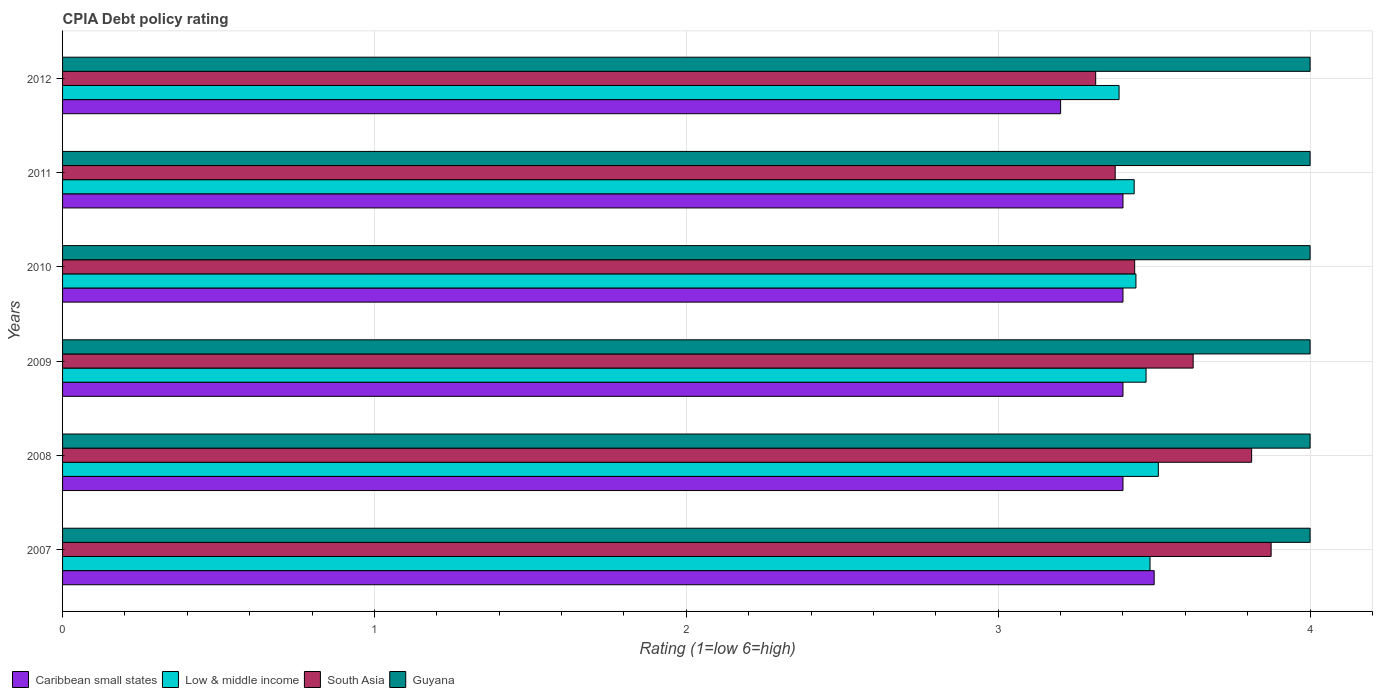How many different coloured bars are there?
Your answer should be compact. 4. Are the number of bars per tick equal to the number of legend labels?
Give a very brief answer. Yes. How many bars are there on the 2nd tick from the top?
Keep it short and to the point. 4. How many bars are there on the 6th tick from the bottom?
Provide a succinct answer. 4. In how many cases, is the number of bars for a given year not equal to the number of legend labels?
Your response must be concise. 0. Across all years, what is the maximum CPIA rating in Guyana?
Make the answer very short. 4. In which year was the CPIA rating in Guyana maximum?
Your answer should be very brief. 2007. What is the total CPIA rating in Low & middle income in the graph?
Your answer should be compact. 20.74. What is the difference between the CPIA rating in Low & middle income in 2009 and that in 2011?
Provide a short and direct response. 0.04. What is the difference between the CPIA rating in Caribbean small states in 2011 and the CPIA rating in South Asia in 2012?
Your response must be concise. 0.09. What is the average CPIA rating in South Asia per year?
Provide a short and direct response. 3.57. In the year 2007, what is the difference between the CPIA rating in Guyana and CPIA rating in Caribbean small states?
Provide a succinct answer. 0.5. In how many years, is the CPIA rating in Caribbean small states greater than 0.6000000000000001 ?
Provide a succinct answer. 6. What is the ratio of the CPIA rating in South Asia in 2010 to that in 2011?
Give a very brief answer. 1.02. What is the difference between the highest and the second highest CPIA rating in Low & middle income?
Your response must be concise. 0.03. What is the difference between the highest and the lowest CPIA rating in Caribbean small states?
Ensure brevity in your answer.  0.3. In how many years, is the CPIA rating in Guyana greater than the average CPIA rating in Guyana taken over all years?
Your response must be concise. 0. Is it the case that in every year, the sum of the CPIA rating in Caribbean small states and CPIA rating in Guyana is greater than the sum of CPIA rating in South Asia and CPIA rating in Low & middle income?
Offer a terse response. Yes. What does the 4th bar from the top in 2012 represents?
Your response must be concise. Caribbean small states. What does the 1st bar from the bottom in 2008 represents?
Make the answer very short. Caribbean small states. Is it the case that in every year, the sum of the CPIA rating in Guyana and CPIA rating in Low & middle income is greater than the CPIA rating in South Asia?
Ensure brevity in your answer.  Yes. How many bars are there?
Your answer should be very brief. 24. Are all the bars in the graph horizontal?
Your answer should be compact. Yes. How many years are there in the graph?
Your answer should be very brief. 6. Are the values on the major ticks of X-axis written in scientific E-notation?
Keep it short and to the point. No. Where does the legend appear in the graph?
Give a very brief answer. Bottom left. How many legend labels are there?
Offer a terse response. 4. What is the title of the graph?
Your answer should be compact. CPIA Debt policy rating. Does "Euro area" appear as one of the legend labels in the graph?
Keep it short and to the point. No. What is the label or title of the X-axis?
Ensure brevity in your answer.  Rating (1=low 6=high). What is the label or title of the Y-axis?
Provide a short and direct response. Years. What is the Rating (1=low 6=high) of Low & middle income in 2007?
Ensure brevity in your answer.  3.49. What is the Rating (1=low 6=high) of South Asia in 2007?
Make the answer very short. 3.88. What is the Rating (1=low 6=high) in Low & middle income in 2008?
Keep it short and to the point. 3.51. What is the Rating (1=low 6=high) of South Asia in 2008?
Make the answer very short. 3.81. What is the Rating (1=low 6=high) in Caribbean small states in 2009?
Offer a terse response. 3.4. What is the Rating (1=low 6=high) in Low & middle income in 2009?
Keep it short and to the point. 3.47. What is the Rating (1=low 6=high) in South Asia in 2009?
Make the answer very short. 3.62. What is the Rating (1=low 6=high) of Guyana in 2009?
Your response must be concise. 4. What is the Rating (1=low 6=high) in Caribbean small states in 2010?
Keep it short and to the point. 3.4. What is the Rating (1=low 6=high) in Low & middle income in 2010?
Make the answer very short. 3.44. What is the Rating (1=low 6=high) in South Asia in 2010?
Give a very brief answer. 3.44. What is the Rating (1=low 6=high) in Guyana in 2010?
Your response must be concise. 4. What is the Rating (1=low 6=high) in Low & middle income in 2011?
Your answer should be very brief. 3.44. What is the Rating (1=low 6=high) in South Asia in 2011?
Provide a succinct answer. 3.38. What is the Rating (1=low 6=high) in Guyana in 2011?
Provide a succinct answer. 4. What is the Rating (1=low 6=high) in Caribbean small states in 2012?
Your answer should be compact. 3.2. What is the Rating (1=low 6=high) in Low & middle income in 2012?
Your response must be concise. 3.39. What is the Rating (1=low 6=high) of South Asia in 2012?
Give a very brief answer. 3.31. What is the Rating (1=low 6=high) of Guyana in 2012?
Provide a short and direct response. 4. Across all years, what is the maximum Rating (1=low 6=high) in Caribbean small states?
Offer a very short reply. 3.5. Across all years, what is the maximum Rating (1=low 6=high) in Low & middle income?
Provide a succinct answer. 3.51. Across all years, what is the maximum Rating (1=low 6=high) in South Asia?
Ensure brevity in your answer.  3.88. Across all years, what is the maximum Rating (1=low 6=high) of Guyana?
Keep it short and to the point. 4. Across all years, what is the minimum Rating (1=low 6=high) in Caribbean small states?
Your answer should be compact. 3.2. Across all years, what is the minimum Rating (1=low 6=high) in Low & middle income?
Your response must be concise. 3.39. Across all years, what is the minimum Rating (1=low 6=high) of South Asia?
Offer a very short reply. 3.31. Across all years, what is the minimum Rating (1=low 6=high) in Guyana?
Your answer should be compact. 4. What is the total Rating (1=low 6=high) in Caribbean small states in the graph?
Your answer should be compact. 20.3. What is the total Rating (1=low 6=high) in Low & middle income in the graph?
Offer a terse response. 20.74. What is the total Rating (1=low 6=high) of South Asia in the graph?
Keep it short and to the point. 21.44. What is the total Rating (1=low 6=high) of Guyana in the graph?
Your answer should be very brief. 24. What is the difference between the Rating (1=low 6=high) in Low & middle income in 2007 and that in 2008?
Your answer should be compact. -0.03. What is the difference between the Rating (1=low 6=high) in South Asia in 2007 and that in 2008?
Offer a very short reply. 0.06. What is the difference between the Rating (1=low 6=high) of Guyana in 2007 and that in 2008?
Offer a very short reply. 0. What is the difference between the Rating (1=low 6=high) in Low & middle income in 2007 and that in 2009?
Give a very brief answer. 0.01. What is the difference between the Rating (1=low 6=high) in South Asia in 2007 and that in 2009?
Your answer should be compact. 0.25. What is the difference between the Rating (1=low 6=high) of Guyana in 2007 and that in 2009?
Offer a terse response. 0. What is the difference between the Rating (1=low 6=high) in Low & middle income in 2007 and that in 2010?
Give a very brief answer. 0.05. What is the difference between the Rating (1=low 6=high) of South Asia in 2007 and that in 2010?
Provide a short and direct response. 0.44. What is the difference between the Rating (1=low 6=high) in Caribbean small states in 2007 and that in 2011?
Your answer should be very brief. 0.1. What is the difference between the Rating (1=low 6=high) in Low & middle income in 2007 and that in 2011?
Provide a short and direct response. 0.05. What is the difference between the Rating (1=low 6=high) of Guyana in 2007 and that in 2011?
Offer a terse response. 0. What is the difference between the Rating (1=low 6=high) of Low & middle income in 2007 and that in 2012?
Keep it short and to the point. 0.1. What is the difference between the Rating (1=low 6=high) in South Asia in 2007 and that in 2012?
Offer a terse response. 0.56. What is the difference between the Rating (1=low 6=high) of Low & middle income in 2008 and that in 2009?
Offer a terse response. 0.04. What is the difference between the Rating (1=low 6=high) in South Asia in 2008 and that in 2009?
Your answer should be compact. 0.19. What is the difference between the Rating (1=low 6=high) of Low & middle income in 2008 and that in 2010?
Provide a succinct answer. 0.07. What is the difference between the Rating (1=low 6=high) in Low & middle income in 2008 and that in 2011?
Keep it short and to the point. 0.08. What is the difference between the Rating (1=low 6=high) in South Asia in 2008 and that in 2011?
Keep it short and to the point. 0.44. What is the difference between the Rating (1=low 6=high) in Caribbean small states in 2008 and that in 2012?
Offer a very short reply. 0.2. What is the difference between the Rating (1=low 6=high) in Low & middle income in 2008 and that in 2012?
Keep it short and to the point. 0.13. What is the difference between the Rating (1=low 6=high) in South Asia in 2008 and that in 2012?
Provide a succinct answer. 0.5. What is the difference between the Rating (1=low 6=high) in Guyana in 2008 and that in 2012?
Provide a succinct answer. 0. What is the difference between the Rating (1=low 6=high) of Caribbean small states in 2009 and that in 2010?
Your answer should be very brief. 0. What is the difference between the Rating (1=low 6=high) in Low & middle income in 2009 and that in 2010?
Your response must be concise. 0.03. What is the difference between the Rating (1=low 6=high) of South Asia in 2009 and that in 2010?
Ensure brevity in your answer.  0.19. What is the difference between the Rating (1=low 6=high) of Low & middle income in 2009 and that in 2011?
Keep it short and to the point. 0.04. What is the difference between the Rating (1=low 6=high) in South Asia in 2009 and that in 2011?
Your answer should be compact. 0.25. What is the difference between the Rating (1=low 6=high) in Caribbean small states in 2009 and that in 2012?
Your answer should be compact. 0.2. What is the difference between the Rating (1=low 6=high) in Low & middle income in 2009 and that in 2012?
Provide a short and direct response. 0.09. What is the difference between the Rating (1=low 6=high) of South Asia in 2009 and that in 2012?
Make the answer very short. 0.31. What is the difference between the Rating (1=low 6=high) of Guyana in 2009 and that in 2012?
Give a very brief answer. 0. What is the difference between the Rating (1=low 6=high) of Caribbean small states in 2010 and that in 2011?
Provide a succinct answer. 0. What is the difference between the Rating (1=low 6=high) in Low & middle income in 2010 and that in 2011?
Ensure brevity in your answer.  0.01. What is the difference between the Rating (1=low 6=high) of South Asia in 2010 and that in 2011?
Your response must be concise. 0.06. What is the difference between the Rating (1=low 6=high) of Caribbean small states in 2010 and that in 2012?
Provide a succinct answer. 0.2. What is the difference between the Rating (1=low 6=high) in Low & middle income in 2010 and that in 2012?
Your answer should be compact. 0.05. What is the difference between the Rating (1=low 6=high) in South Asia in 2010 and that in 2012?
Your answer should be very brief. 0.12. What is the difference between the Rating (1=low 6=high) in Guyana in 2010 and that in 2012?
Provide a short and direct response. 0. What is the difference between the Rating (1=low 6=high) of Low & middle income in 2011 and that in 2012?
Provide a short and direct response. 0.05. What is the difference between the Rating (1=low 6=high) of South Asia in 2011 and that in 2012?
Offer a terse response. 0.06. What is the difference between the Rating (1=low 6=high) in Caribbean small states in 2007 and the Rating (1=low 6=high) in Low & middle income in 2008?
Offer a terse response. -0.01. What is the difference between the Rating (1=low 6=high) of Caribbean small states in 2007 and the Rating (1=low 6=high) of South Asia in 2008?
Offer a terse response. -0.31. What is the difference between the Rating (1=low 6=high) of Caribbean small states in 2007 and the Rating (1=low 6=high) of Guyana in 2008?
Ensure brevity in your answer.  -0.5. What is the difference between the Rating (1=low 6=high) of Low & middle income in 2007 and the Rating (1=low 6=high) of South Asia in 2008?
Offer a very short reply. -0.33. What is the difference between the Rating (1=low 6=high) in Low & middle income in 2007 and the Rating (1=low 6=high) in Guyana in 2008?
Give a very brief answer. -0.51. What is the difference between the Rating (1=low 6=high) in South Asia in 2007 and the Rating (1=low 6=high) in Guyana in 2008?
Give a very brief answer. -0.12. What is the difference between the Rating (1=low 6=high) of Caribbean small states in 2007 and the Rating (1=low 6=high) of Low & middle income in 2009?
Offer a terse response. 0.03. What is the difference between the Rating (1=low 6=high) in Caribbean small states in 2007 and the Rating (1=low 6=high) in South Asia in 2009?
Your answer should be very brief. -0.12. What is the difference between the Rating (1=low 6=high) of Caribbean small states in 2007 and the Rating (1=low 6=high) of Guyana in 2009?
Your answer should be compact. -0.5. What is the difference between the Rating (1=low 6=high) in Low & middle income in 2007 and the Rating (1=low 6=high) in South Asia in 2009?
Make the answer very short. -0.14. What is the difference between the Rating (1=low 6=high) of Low & middle income in 2007 and the Rating (1=low 6=high) of Guyana in 2009?
Provide a short and direct response. -0.51. What is the difference between the Rating (1=low 6=high) of South Asia in 2007 and the Rating (1=low 6=high) of Guyana in 2009?
Offer a terse response. -0.12. What is the difference between the Rating (1=low 6=high) of Caribbean small states in 2007 and the Rating (1=low 6=high) of Low & middle income in 2010?
Keep it short and to the point. 0.06. What is the difference between the Rating (1=low 6=high) in Caribbean small states in 2007 and the Rating (1=low 6=high) in South Asia in 2010?
Your answer should be very brief. 0.06. What is the difference between the Rating (1=low 6=high) of Caribbean small states in 2007 and the Rating (1=low 6=high) of Guyana in 2010?
Your answer should be compact. -0.5. What is the difference between the Rating (1=low 6=high) of Low & middle income in 2007 and the Rating (1=low 6=high) of South Asia in 2010?
Your answer should be very brief. 0.05. What is the difference between the Rating (1=low 6=high) of Low & middle income in 2007 and the Rating (1=low 6=high) of Guyana in 2010?
Offer a very short reply. -0.51. What is the difference between the Rating (1=low 6=high) in South Asia in 2007 and the Rating (1=low 6=high) in Guyana in 2010?
Offer a very short reply. -0.12. What is the difference between the Rating (1=low 6=high) in Caribbean small states in 2007 and the Rating (1=low 6=high) in Low & middle income in 2011?
Offer a very short reply. 0.06. What is the difference between the Rating (1=low 6=high) of Low & middle income in 2007 and the Rating (1=low 6=high) of South Asia in 2011?
Provide a short and direct response. 0.11. What is the difference between the Rating (1=low 6=high) in Low & middle income in 2007 and the Rating (1=low 6=high) in Guyana in 2011?
Offer a terse response. -0.51. What is the difference between the Rating (1=low 6=high) in South Asia in 2007 and the Rating (1=low 6=high) in Guyana in 2011?
Provide a succinct answer. -0.12. What is the difference between the Rating (1=low 6=high) of Caribbean small states in 2007 and the Rating (1=low 6=high) of Low & middle income in 2012?
Your response must be concise. 0.11. What is the difference between the Rating (1=low 6=high) of Caribbean small states in 2007 and the Rating (1=low 6=high) of South Asia in 2012?
Your response must be concise. 0.19. What is the difference between the Rating (1=low 6=high) of Low & middle income in 2007 and the Rating (1=low 6=high) of South Asia in 2012?
Ensure brevity in your answer.  0.17. What is the difference between the Rating (1=low 6=high) in Low & middle income in 2007 and the Rating (1=low 6=high) in Guyana in 2012?
Keep it short and to the point. -0.51. What is the difference between the Rating (1=low 6=high) in South Asia in 2007 and the Rating (1=low 6=high) in Guyana in 2012?
Your answer should be very brief. -0.12. What is the difference between the Rating (1=low 6=high) in Caribbean small states in 2008 and the Rating (1=low 6=high) in Low & middle income in 2009?
Your response must be concise. -0.07. What is the difference between the Rating (1=low 6=high) in Caribbean small states in 2008 and the Rating (1=low 6=high) in South Asia in 2009?
Keep it short and to the point. -0.23. What is the difference between the Rating (1=low 6=high) in Low & middle income in 2008 and the Rating (1=low 6=high) in South Asia in 2009?
Make the answer very short. -0.11. What is the difference between the Rating (1=low 6=high) in Low & middle income in 2008 and the Rating (1=low 6=high) in Guyana in 2009?
Provide a succinct answer. -0.49. What is the difference between the Rating (1=low 6=high) in South Asia in 2008 and the Rating (1=low 6=high) in Guyana in 2009?
Provide a short and direct response. -0.19. What is the difference between the Rating (1=low 6=high) of Caribbean small states in 2008 and the Rating (1=low 6=high) of Low & middle income in 2010?
Provide a short and direct response. -0.04. What is the difference between the Rating (1=low 6=high) in Caribbean small states in 2008 and the Rating (1=low 6=high) in South Asia in 2010?
Your answer should be very brief. -0.04. What is the difference between the Rating (1=low 6=high) in Caribbean small states in 2008 and the Rating (1=low 6=high) in Guyana in 2010?
Your answer should be very brief. -0.6. What is the difference between the Rating (1=low 6=high) in Low & middle income in 2008 and the Rating (1=low 6=high) in South Asia in 2010?
Give a very brief answer. 0.08. What is the difference between the Rating (1=low 6=high) of Low & middle income in 2008 and the Rating (1=low 6=high) of Guyana in 2010?
Your response must be concise. -0.49. What is the difference between the Rating (1=low 6=high) in South Asia in 2008 and the Rating (1=low 6=high) in Guyana in 2010?
Ensure brevity in your answer.  -0.19. What is the difference between the Rating (1=low 6=high) of Caribbean small states in 2008 and the Rating (1=low 6=high) of Low & middle income in 2011?
Keep it short and to the point. -0.04. What is the difference between the Rating (1=low 6=high) of Caribbean small states in 2008 and the Rating (1=low 6=high) of South Asia in 2011?
Offer a terse response. 0.03. What is the difference between the Rating (1=low 6=high) of Low & middle income in 2008 and the Rating (1=low 6=high) of South Asia in 2011?
Your answer should be very brief. 0.14. What is the difference between the Rating (1=low 6=high) in Low & middle income in 2008 and the Rating (1=low 6=high) in Guyana in 2011?
Provide a succinct answer. -0.49. What is the difference between the Rating (1=low 6=high) of South Asia in 2008 and the Rating (1=low 6=high) of Guyana in 2011?
Offer a terse response. -0.19. What is the difference between the Rating (1=low 6=high) in Caribbean small states in 2008 and the Rating (1=low 6=high) in Low & middle income in 2012?
Your answer should be compact. 0.01. What is the difference between the Rating (1=low 6=high) in Caribbean small states in 2008 and the Rating (1=low 6=high) in South Asia in 2012?
Offer a very short reply. 0.09. What is the difference between the Rating (1=low 6=high) in Low & middle income in 2008 and the Rating (1=low 6=high) in South Asia in 2012?
Offer a very short reply. 0.2. What is the difference between the Rating (1=low 6=high) in Low & middle income in 2008 and the Rating (1=low 6=high) in Guyana in 2012?
Give a very brief answer. -0.49. What is the difference between the Rating (1=low 6=high) of South Asia in 2008 and the Rating (1=low 6=high) of Guyana in 2012?
Keep it short and to the point. -0.19. What is the difference between the Rating (1=low 6=high) of Caribbean small states in 2009 and the Rating (1=low 6=high) of Low & middle income in 2010?
Your answer should be very brief. -0.04. What is the difference between the Rating (1=low 6=high) of Caribbean small states in 2009 and the Rating (1=low 6=high) of South Asia in 2010?
Provide a succinct answer. -0.04. What is the difference between the Rating (1=low 6=high) in Low & middle income in 2009 and the Rating (1=low 6=high) in South Asia in 2010?
Your answer should be very brief. 0.04. What is the difference between the Rating (1=low 6=high) in Low & middle income in 2009 and the Rating (1=low 6=high) in Guyana in 2010?
Provide a succinct answer. -0.53. What is the difference between the Rating (1=low 6=high) in South Asia in 2009 and the Rating (1=low 6=high) in Guyana in 2010?
Give a very brief answer. -0.38. What is the difference between the Rating (1=low 6=high) in Caribbean small states in 2009 and the Rating (1=low 6=high) in Low & middle income in 2011?
Keep it short and to the point. -0.04. What is the difference between the Rating (1=low 6=high) of Caribbean small states in 2009 and the Rating (1=low 6=high) of South Asia in 2011?
Give a very brief answer. 0.03. What is the difference between the Rating (1=low 6=high) of Caribbean small states in 2009 and the Rating (1=low 6=high) of Guyana in 2011?
Provide a succinct answer. -0.6. What is the difference between the Rating (1=low 6=high) of Low & middle income in 2009 and the Rating (1=low 6=high) of South Asia in 2011?
Give a very brief answer. 0.1. What is the difference between the Rating (1=low 6=high) in Low & middle income in 2009 and the Rating (1=low 6=high) in Guyana in 2011?
Provide a succinct answer. -0.53. What is the difference between the Rating (1=low 6=high) of South Asia in 2009 and the Rating (1=low 6=high) of Guyana in 2011?
Offer a terse response. -0.38. What is the difference between the Rating (1=low 6=high) of Caribbean small states in 2009 and the Rating (1=low 6=high) of Low & middle income in 2012?
Give a very brief answer. 0.01. What is the difference between the Rating (1=low 6=high) of Caribbean small states in 2009 and the Rating (1=low 6=high) of South Asia in 2012?
Give a very brief answer. 0.09. What is the difference between the Rating (1=low 6=high) in Low & middle income in 2009 and the Rating (1=low 6=high) in South Asia in 2012?
Your response must be concise. 0.16. What is the difference between the Rating (1=low 6=high) in Low & middle income in 2009 and the Rating (1=low 6=high) in Guyana in 2012?
Offer a very short reply. -0.53. What is the difference between the Rating (1=low 6=high) in South Asia in 2009 and the Rating (1=low 6=high) in Guyana in 2012?
Make the answer very short. -0.38. What is the difference between the Rating (1=low 6=high) of Caribbean small states in 2010 and the Rating (1=low 6=high) of Low & middle income in 2011?
Ensure brevity in your answer.  -0.04. What is the difference between the Rating (1=low 6=high) of Caribbean small states in 2010 and the Rating (1=low 6=high) of South Asia in 2011?
Offer a very short reply. 0.03. What is the difference between the Rating (1=low 6=high) in Low & middle income in 2010 and the Rating (1=low 6=high) in South Asia in 2011?
Ensure brevity in your answer.  0.07. What is the difference between the Rating (1=low 6=high) of Low & middle income in 2010 and the Rating (1=low 6=high) of Guyana in 2011?
Your answer should be compact. -0.56. What is the difference between the Rating (1=low 6=high) in South Asia in 2010 and the Rating (1=low 6=high) in Guyana in 2011?
Provide a short and direct response. -0.56. What is the difference between the Rating (1=low 6=high) in Caribbean small states in 2010 and the Rating (1=low 6=high) in Low & middle income in 2012?
Provide a succinct answer. 0.01. What is the difference between the Rating (1=low 6=high) in Caribbean small states in 2010 and the Rating (1=low 6=high) in South Asia in 2012?
Offer a terse response. 0.09. What is the difference between the Rating (1=low 6=high) of Caribbean small states in 2010 and the Rating (1=low 6=high) of Guyana in 2012?
Make the answer very short. -0.6. What is the difference between the Rating (1=low 6=high) of Low & middle income in 2010 and the Rating (1=low 6=high) of South Asia in 2012?
Provide a short and direct response. 0.13. What is the difference between the Rating (1=low 6=high) in Low & middle income in 2010 and the Rating (1=low 6=high) in Guyana in 2012?
Your response must be concise. -0.56. What is the difference between the Rating (1=low 6=high) in South Asia in 2010 and the Rating (1=low 6=high) in Guyana in 2012?
Provide a succinct answer. -0.56. What is the difference between the Rating (1=low 6=high) in Caribbean small states in 2011 and the Rating (1=low 6=high) in Low & middle income in 2012?
Provide a short and direct response. 0.01. What is the difference between the Rating (1=low 6=high) of Caribbean small states in 2011 and the Rating (1=low 6=high) of South Asia in 2012?
Your answer should be compact. 0.09. What is the difference between the Rating (1=low 6=high) in Caribbean small states in 2011 and the Rating (1=low 6=high) in Guyana in 2012?
Keep it short and to the point. -0.6. What is the difference between the Rating (1=low 6=high) in Low & middle income in 2011 and the Rating (1=low 6=high) in South Asia in 2012?
Give a very brief answer. 0.12. What is the difference between the Rating (1=low 6=high) in Low & middle income in 2011 and the Rating (1=low 6=high) in Guyana in 2012?
Your answer should be compact. -0.56. What is the difference between the Rating (1=low 6=high) in South Asia in 2011 and the Rating (1=low 6=high) in Guyana in 2012?
Provide a succinct answer. -0.62. What is the average Rating (1=low 6=high) in Caribbean small states per year?
Your response must be concise. 3.38. What is the average Rating (1=low 6=high) in Low & middle income per year?
Ensure brevity in your answer.  3.46. What is the average Rating (1=low 6=high) in South Asia per year?
Your answer should be compact. 3.57. In the year 2007, what is the difference between the Rating (1=low 6=high) in Caribbean small states and Rating (1=low 6=high) in Low & middle income?
Your answer should be compact. 0.01. In the year 2007, what is the difference between the Rating (1=low 6=high) in Caribbean small states and Rating (1=low 6=high) in South Asia?
Offer a terse response. -0.38. In the year 2007, what is the difference between the Rating (1=low 6=high) of Caribbean small states and Rating (1=low 6=high) of Guyana?
Your answer should be very brief. -0.5. In the year 2007, what is the difference between the Rating (1=low 6=high) in Low & middle income and Rating (1=low 6=high) in South Asia?
Provide a short and direct response. -0.39. In the year 2007, what is the difference between the Rating (1=low 6=high) of Low & middle income and Rating (1=low 6=high) of Guyana?
Give a very brief answer. -0.51. In the year 2007, what is the difference between the Rating (1=low 6=high) of South Asia and Rating (1=low 6=high) of Guyana?
Your answer should be compact. -0.12. In the year 2008, what is the difference between the Rating (1=low 6=high) of Caribbean small states and Rating (1=low 6=high) of Low & middle income?
Offer a very short reply. -0.11. In the year 2008, what is the difference between the Rating (1=low 6=high) of Caribbean small states and Rating (1=low 6=high) of South Asia?
Make the answer very short. -0.41. In the year 2008, what is the difference between the Rating (1=low 6=high) of Low & middle income and Rating (1=low 6=high) of South Asia?
Keep it short and to the point. -0.3. In the year 2008, what is the difference between the Rating (1=low 6=high) in Low & middle income and Rating (1=low 6=high) in Guyana?
Keep it short and to the point. -0.49. In the year 2008, what is the difference between the Rating (1=low 6=high) in South Asia and Rating (1=low 6=high) in Guyana?
Give a very brief answer. -0.19. In the year 2009, what is the difference between the Rating (1=low 6=high) of Caribbean small states and Rating (1=low 6=high) of Low & middle income?
Make the answer very short. -0.07. In the year 2009, what is the difference between the Rating (1=low 6=high) of Caribbean small states and Rating (1=low 6=high) of South Asia?
Ensure brevity in your answer.  -0.23. In the year 2009, what is the difference between the Rating (1=low 6=high) of Low & middle income and Rating (1=low 6=high) of South Asia?
Your answer should be very brief. -0.15. In the year 2009, what is the difference between the Rating (1=low 6=high) in Low & middle income and Rating (1=low 6=high) in Guyana?
Your response must be concise. -0.53. In the year 2009, what is the difference between the Rating (1=low 6=high) of South Asia and Rating (1=low 6=high) of Guyana?
Offer a terse response. -0.38. In the year 2010, what is the difference between the Rating (1=low 6=high) in Caribbean small states and Rating (1=low 6=high) in Low & middle income?
Give a very brief answer. -0.04. In the year 2010, what is the difference between the Rating (1=low 6=high) in Caribbean small states and Rating (1=low 6=high) in South Asia?
Keep it short and to the point. -0.04. In the year 2010, what is the difference between the Rating (1=low 6=high) in Caribbean small states and Rating (1=low 6=high) in Guyana?
Your answer should be compact. -0.6. In the year 2010, what is the difference between the Rating (1=low 6=high) in Low & middle income and Rating (1=low 6=high) in South Asia?
Provide a short and direct response. 0. In the year 2010, what is the difference between the Rating (1=low 6=high) of Low & middle income and Rating (1=low 6=high) of Guyana?
Offer a terse response. -0.56. In the year 2010, what is the difference between the Rating (1=low 6=high) in South Asia and Rating (1=low 6=high) in Guyana?
Give a very brief answer. -0.56. In the year 2011, what is the difference between the Rating (1=low 6=high) in Caribbean small states and Rating (1=low 6=high) in Low & middle income?
Your response must be concise. -0.04. In the year 2011, what is the difference between the Rating (1=low 6=high) in Caribbean small states and Rating (1=low 6=high) in South Asia?
Your response must be concise. 0.03. In the year 2011, what is the difference between the Rating (1=low 6=high) in Low & middle income and Rating (1=low 6=high) in South Asia?
Provide a short and direct response. 0.06. In the year 2011, what is the difference between the Rating (1=low 6=high) in Low & middle income and Rating (1=low 6=high) in Guyana?
Provide a succinct answer. -0.56. In the year 2011, what is the difference between the Rating (1=low 6=high) in South Asia and Rating (1=low 6=high) in Guyana?
Ensure brevity in your answer.  -0.62. In the year 2012, what is the difference between the Rating (1=low 6=high) in Caribbean small states and Rating (1=low 6=high) in Low & middle income?
Make the answer very short. -0.19. In the year 2012, what is the difference between the Rating (1=low 6=high) in Caribbean small states and Rating (1=low 6=high) in South Asia?
Provide a succinct answer. -0.11. In the year 2012, what is the difference between the Rating (1=low 6=high) of Caribbean small states and Rating (1=low 6=high) of Guyana?
Offer a terse response. -0.8. In the year 2012, what is the difference between the Rating (1=low 6=high) of Low & middle income and Rating (1=low 6=high) of South Asia?
Your answer should be compact. 0.07. In the year 2012, what is the difference between the Rating (1=low 6=high) of Low & middle income and Rating (1=low 6=high) of Guyana?
Make the answer very short. -0.61. In the year 2012, what is the difference between the Rating (1=low 6=high) in South Asia and Rating (1=low 6=high) in Guyana?
Offer a very short reply. -0.69. What is the ratio of the Rating (1=low 6=high) of Caribbean small states in 2007 to that in 2008?
Provide a short and direct response. 1.03. What is the ratio of the Rating (1=low 6=high) in South Asia in 2007 to that in 2008?
Offer a very short reply. 1.02. What is the ratio of the Rating (1=low 6=high) in Guyana in 2007 to that in 2008?
Keep it short and to the point. 1. What is the ratio of the Rating (1=low 6=high) in Caribbean small states in 2007 to that in 2009?
Your response must be concise. 1.03. What is the ratio of the Rating (1=low 6=high) in South Asia in 2007 to that in 2009?
Ensure brevity in your answer.  1.07. What is the ratio of the Rating (1=low 6=high) of Guyana in 2007 to that in 2009?
Make the answer very short. 1. What is the ratio of the Rating (1=low 6=high) in Caribbean small states in 2007 to that in 2010?
Your answer should be very brief. 1.03. What is the ratio of the Rating (1=low 6=high) of Low & middle income in 2007 to that in 2010?
Keep it short and to the point. 1.01. What is the ratio of the Rating (1=low 6=high) in South Asia in 2007 to that in 2010?
Ensure brevity in your answer.  1.13. What is the ratio of the Rating (1=low 6=high) in Caribbean small states in 2007 to that in 2011?
Keep it short and to the point. 1.03. What is the ratio of the Rating (1=low 6=high) of Low & middle income in 2007 to that in 2011?
Offer a very short reply. 1.01. What is the ratio of the Rating (1=low 6=high) of South Asia in 2007 to that in 2011?
Provide a short and direct response. 1.15. What is the ratio of the Rating (1=low 6=high) of Guyana in 2007 to that in 2011?
Offer a terse response. 1. What is the ratio of the Rating (1=low 6=high) of Caribbean small states in 2007 to that in 2012?
Your response must be concise. 1.09. What is the ratio of the Rating (1=low 6=high) of Low & middle income in 2007 to that in 2012?
Your answer should be very brief. 1.03. What is the ratio of the Rating (1=low 6=high) of South Asia in 2007 to that in 2012?
Offer a terse response. 1.17. What is the ratio of the Rating (1=low 6=high) in Caribbean small states in 2008 to that in 2009?
Your answer should be very brief. 1. What is the ratio of the Rating (1=low 6=high) in Low & middle income in 2008 to that in 2009?
Your response must be concise. 1.01. What is the ratio of the Rating (1=low 6=high) in South Asia in 2008 to that in 2009?
Offer a very short reply. 1.05. What is the ratio of the Rating (1=low 6=high) of Low & middle income in 2008 to that in 2010?
Keep it short and to the point. 1.02. What is the ratio of the Rating (1=low 6=high) of South Asia in 2008 to that in 2010?
Provide a short and direct response. 1.11. What is the ratio of the Rating (1=low 6=high) in Low & middle income in 2008 to that in 2011?
Your answer should be very brief. 1.02. What is the ratio of the Rating (1=low 6=high) of South Asia in 2008 to that in 2011?
Ensure brevity in your answer.  1.13. What is the ratio of the Rating (1=low 6=high) in Guyana in 2008 to that in 2011?
Your answer should be compact. 1. What is the ratio of the Rating (1=low 6=high) of Low & middle income in 2008 to that in 2012?
Your response must be concise. 1.04. What is the ratio of the Rating (1=low 6=high) in South Asia in 2008 to that in 2012?
Offer a terse response. 1.15. What is the ratio of the Rating (1=low 6=high) of Caribbean small states in 2009 to that in 2010?
Your answer should be very brief. 1. What is the ratio of the Rating (1=low 6=high) of Low & middle income in 2009 to that in 2010?
Keep it short and to the point. 1.01. What is the ratio of the Rating (1=low 6=high) of South Asia in 2009 to that in 2010?
Ensure brevity in your answer.  1.05. What is the ratio of the Rating (1=low 6=high) of Low & middle income in 2009 to that in 2011?
Make the answer very short. 1.01. What is the ratio of the Rating (1=low 6=high) in South Asia in 2009 to that in 2011?
Provide a short and direct response. 1.07. What is the ratio of the Rating (1=low 6=high) of Low & middle income in 2009 to that in 2012?
Provide a short and direct response. 1.03. What is the ratio of the Rating (1=low 6=high) of South Asia in 2009 to that in 2012?
Make the answer very short. 1.09. What is the ratio of the Rating (1=low 6=high) in Low & middle income in 2010 to that in 2011?
Your answer should be compact. 1. What is the ratio of the Rating (1=low 6=high) in South Asia in 2010 to that in 2011?
Your answer should be very brief. 1.02. What is the ratio of the Rating (1=low 6=high) in Guyana in 2010 to that in 2011?
Give a very brief answer. 1. What is the ratio of the Rating (1=low 6=high) in Caribbean small states in 2010 to that in 2012?
Offer a terse response. 1.06. What is the ratio of the Rating (1=low 6=high) of Low & middle income in 2010 to that in 2012?
Make the answer very short. 1.02. What is the ratio of the Rating (1=low 6=high) of South Asia in 2010 to that in 2012?
Provide a succinct answer. 1.04. What is the ratio of the Rating (1=low 6=high) of Guyana in 2010 to that in 2012?
Give a very brief answer. 1. What is the ratio of the Rating (1=low 6=high) in Low & middle income in 2011 to that in 2012?
Your response must be concise. 1.01. What is the ratio of the Rating (1=low 6=high) in South Asia in 2011 to that in 2012?
Provide a short and direct response. 1.02. What is the difference between the highest and the second highest Rating (1=low 6=high) in Caribbean small states?
Keep it short and to the point. 0.1. What is the difference between the highest and the second highest Rating (1=low 6=high) of Low & middle income?
Offer a terse response. 0.03. What is the difference between the highest and the second highest Rating (1=low 6=high) of South Asia?
Ensure brevity in your answer.  0.06. What is the difference between the highest and the lowest Rating (1=low 6=high) of Low & middle income?
Give a very brief answer. 0.13. What is the difference between the highest and the lowest Rating (1=low 6=high) in South Asia?
Make the answer very short. 0.56. What is the difference between the highest and the lowest Rating (1=low 6=high) of Guyana?
Your response must be concise. 0. 